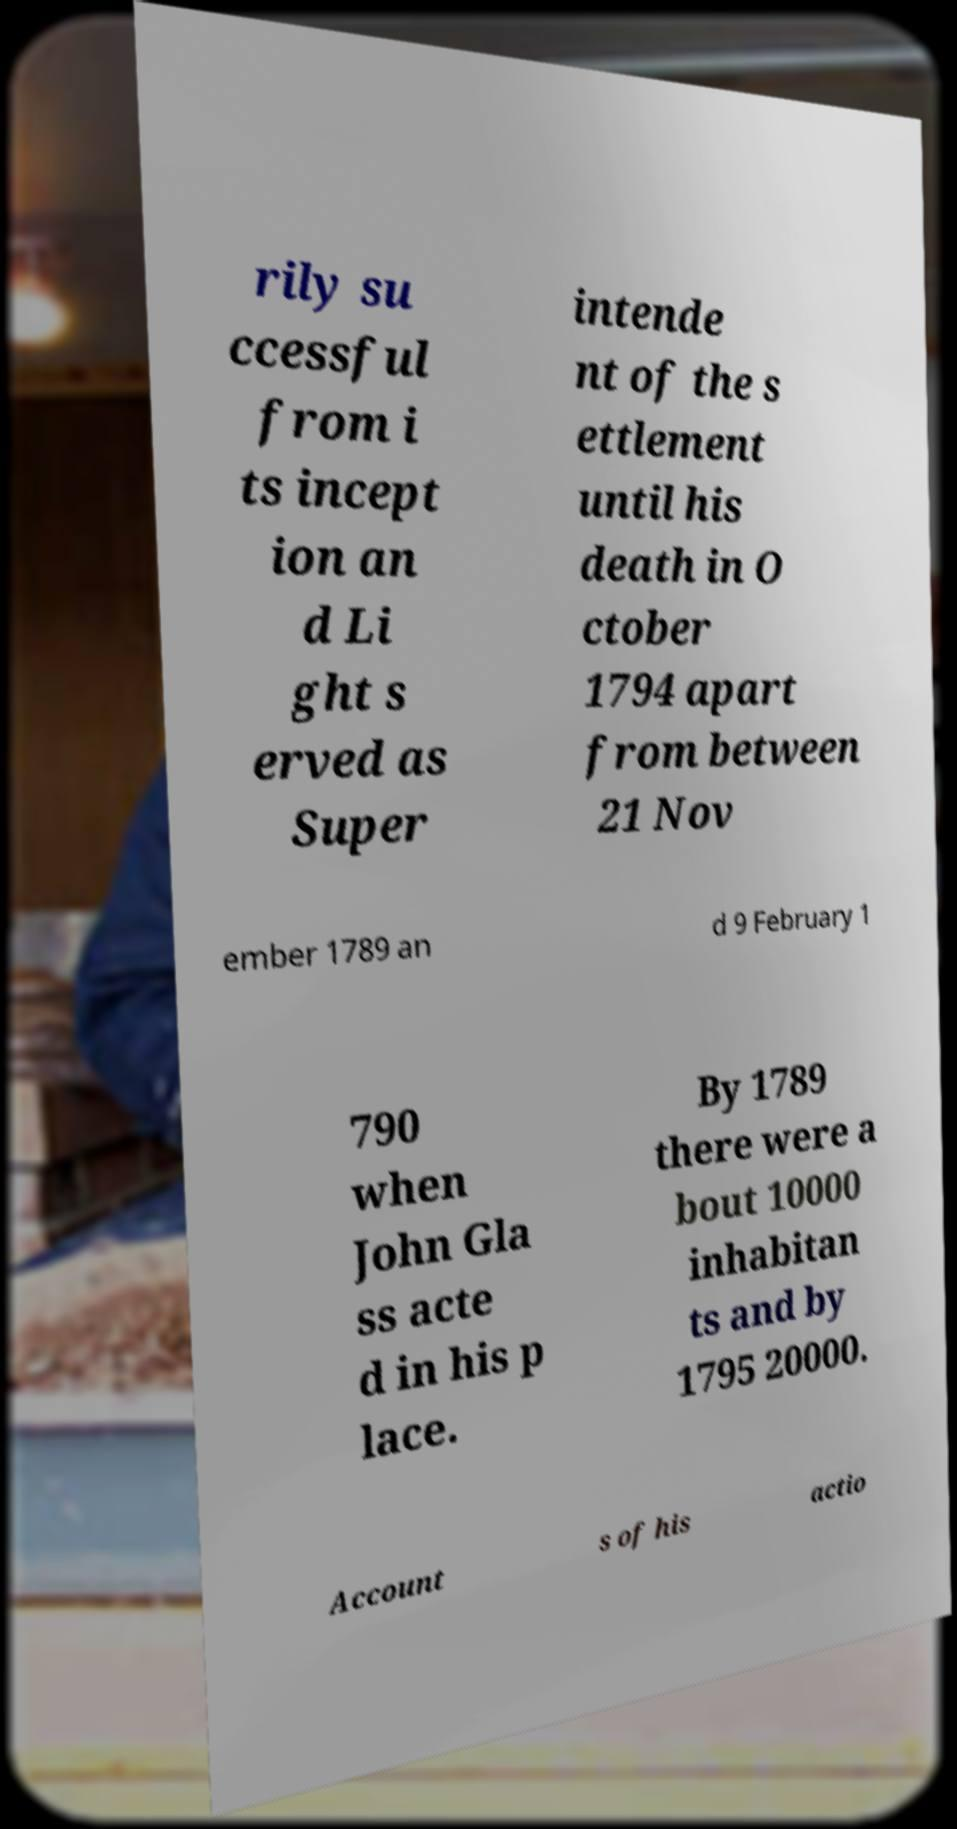Could you extract and type out the text from this image? rily su ccessful from i ts incept ion an d Li ght s erved as Super intende nt of the s ettlement until his death in O ctober 1794 apart from between 21 Nov ember 1789 an d 9 February 1 790 when John Gla ss acte d in his p lace. By 1789 there were a bout 10000 inhabitan ts and by 1795 20000. Account s of his actio 